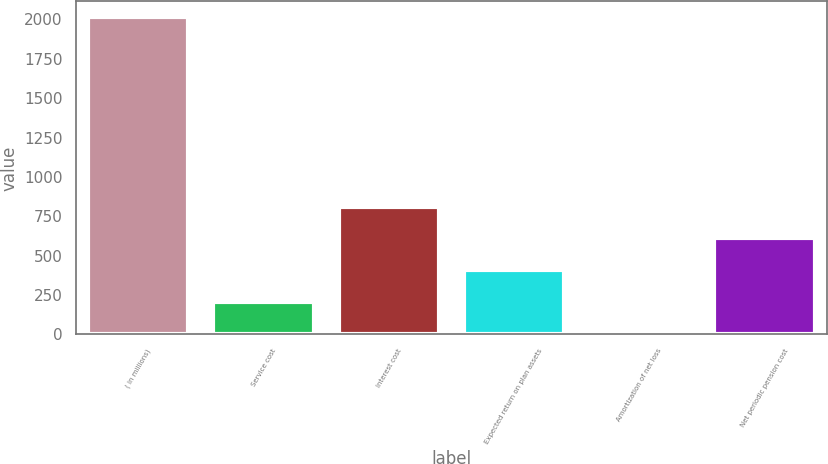<chart> <loc_0><loc_0><loc_500><loc_500><bar_chart><fcel>( in millions)<fcel>Service cost<fcel>Interest cost<fcel>Expected return on plan assets<fcel>Amortization of net loss<fcel>Net periodic pension cost<nl><fcel>2014<fcel>207.7<fcel>809.8<fcel>408.4<fcel>7<fcel>609.1<nl></chart> 